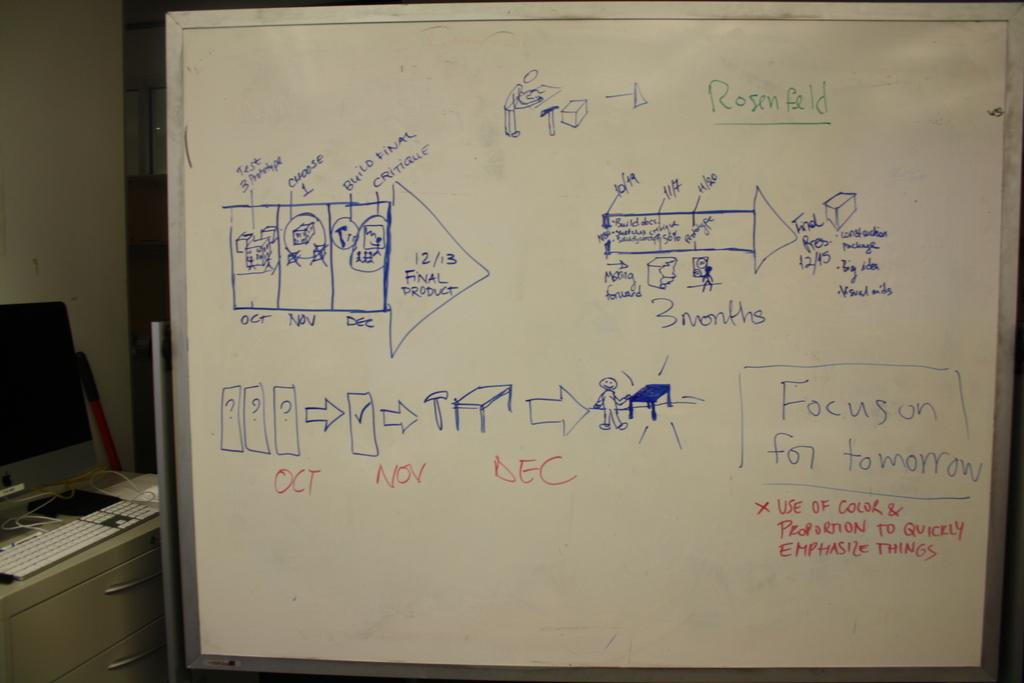<image>
Describe the image concisely. a white board with Rosenfeld written on it in green 